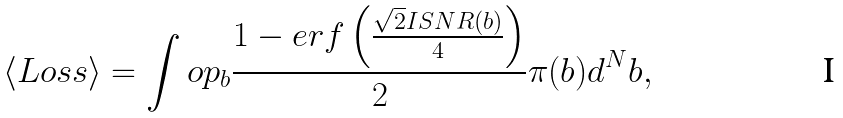<formula> <loc_0><loc_0><loc_500><loc_500>\langle L o s s \rangle = \int o p _ { b } \frac { 1 - e r f \left ( \frac { \sqrt { 2 } I S N R ( b ) } { 4 } \right ) } { 2 } \pi ( b ) d ^ { N } b ,</formula> 